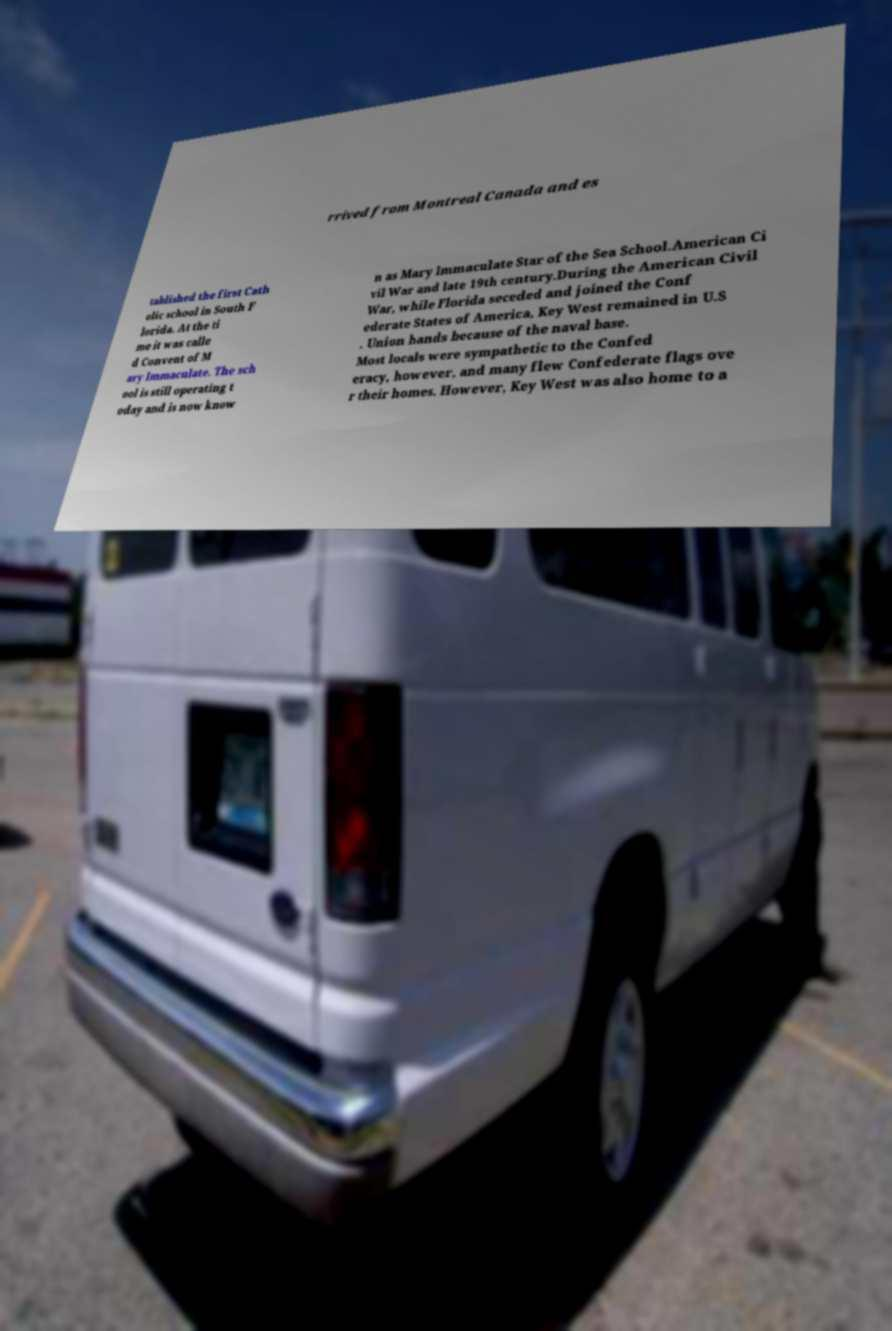There's text embedded in this image that I need extracted. Can you transcribe it verbatim? rrived from Montreal Canada and es tablished the first Cath olic school in South F lorida. At the ti me it was calle d Convent of M ary Immaculate. The sch ool is still operating t oday and is now know n as Mary Immaculate Star of the Sea School.American Ci vil War and late 19th century.During the American Civil War, while Florida seceded and joined the Conf ederate States of America, Key West remained in U.S . Union hands because of the naval base. Most locals were sympathetic to the Confed eracy, however, and many flew Confederate flags ove r their homes. However, Key West was also home to a 